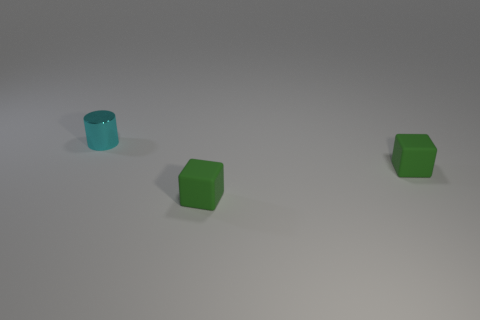There is a tiny shiny thing; are there any cubes behind it? no 